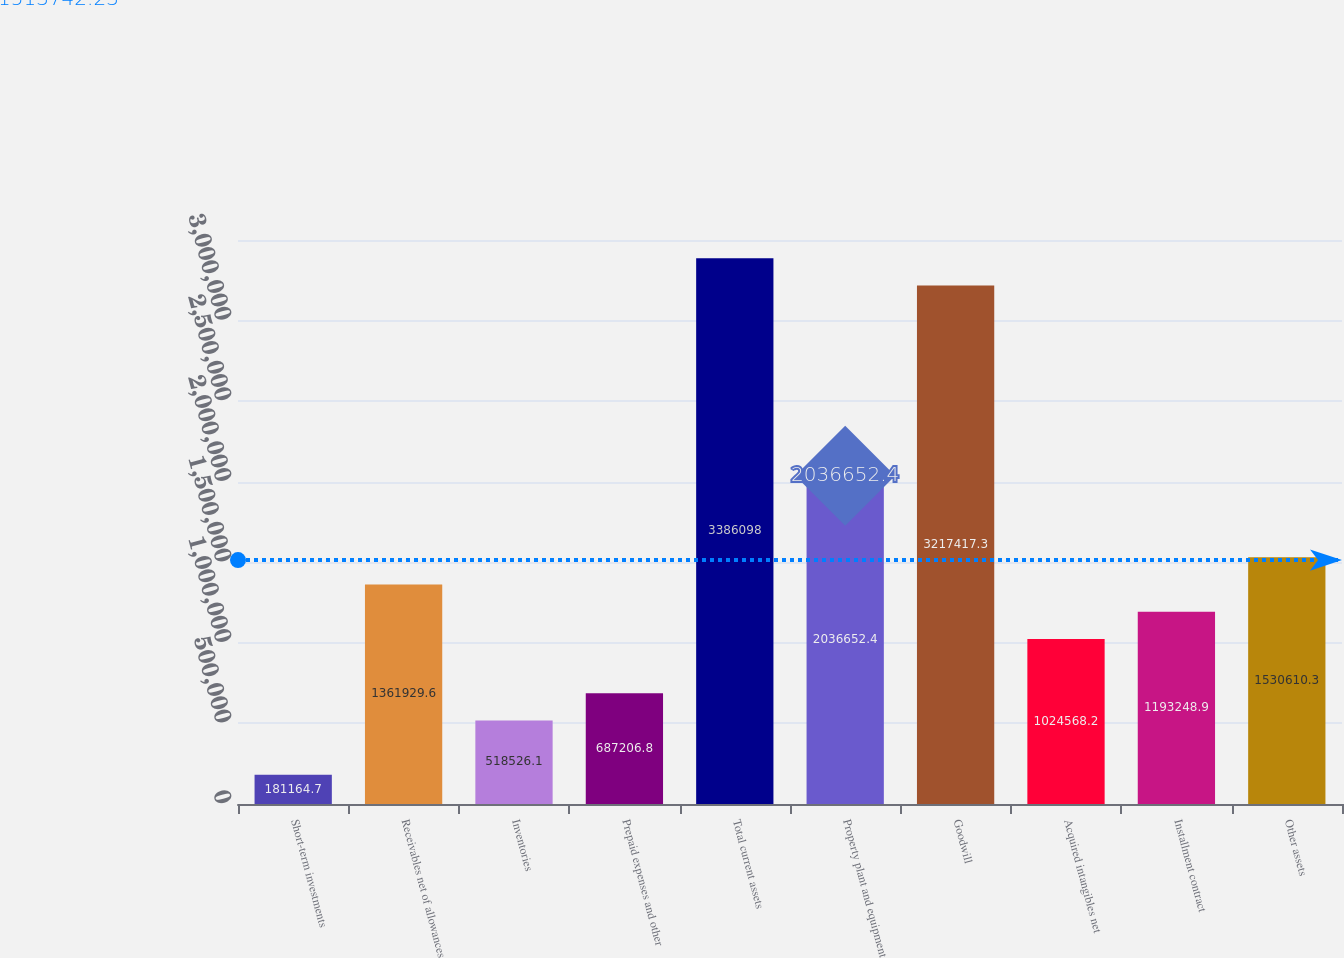<chart> <loc_0><loc_0><loc_500><loc_500><bar_chart><fcel>Short-term investments<fcel>Receivables net of allowances<fcel>Inventories<fcel>Prepaid expenses and other<fcel>Total current assets<fcel>Property plant and equipment<fcel>Goodwill<fcel>Acquired intangibles net<fcel>Installment contract<fcel>Other assets<nl><fcel>181165<fcel>1.36193e+06<fcel>518526<fcel>687207<fcel>3.3861e+06<fcel>2.03665e+06<fcel>3.21742e+06<fcel>1.02457e+06<fcel>1.19325e+06<fcel>1.53061e+06<nl></chart> 